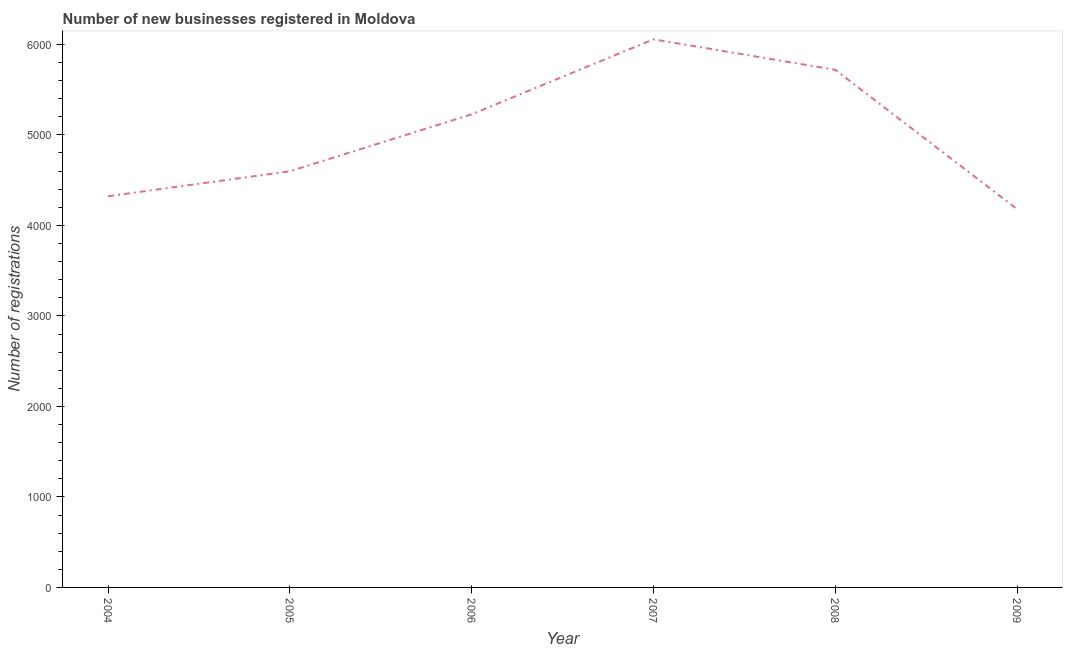What is the number of new business registrations in 2008?
Keep it short and to the point. 5719. Across all years, what is the maximum number of new business registrations?
Offer a very short reply. 6056. Across all years, what is the minimum number of new business registrations?
Provide a short and direct response. 4180. In which year was the number of new business registrations minimum?
Your response must be concise. 2009. What is the sum of the number of new business registrations?
Your answer should be compact. 3.01e+04. What is the difference between the number of new business registrations in 2004 and 2009?
Offer a terse response. 142. What is the average number of new business registrations per year?
Your response must be concise. 5017. What is the median number of new business registrations?
Offer a very short reply. 4912.5. In how many years, is the number of new business registrations greater than 4400 ?
Your answer should be compact. 4. Do a majority of the years between 2005 and 2008 (inclusive) have number of new business registrations greater than 4600 ?
Offer a very short reply. Yes. What is the ratio of the number of new business registrations in 2005 to that in 2009?
Offer a very short reply. 1.1. Is the number of new business registrations in 2004 less than that in 2006?
Keep it short and to the point. Yes. Is the difference between the number of new business registrations in 2005 and 2008 greater than the difference between any two years?
Keep it short and to the point. No. What is the difference between the highest and the second highest number of new business registrations?
Ensure brevity in your answer.  337. What is the difference between the highest and the lowest number of new business registrations?
Ensure brevity in your answer.  1876. Does the number of new business registrations monotonically increase over the years?
Your answer should be compact. No. How many lines are there?
Keep it short and to the point. 1. How many years are there in the graph?
Keep it short and to the point. 6. What is the difference between two consecutive major ticks on the Y-axis?
Your answer should be very brief. 1000. What is the title of the graph?
Offer a terse response. Number of new businesses registered in Moldova. What is the label or title of the Y-axis?
Your answer should be compact. Number of registrations. What is the Number of registrations of 2004?
Keep it short and to the point. 4322. What is the Number of registrations in 2005?
Give a very brief answer. 4598. What is the Number of registrations in 2006?
Your response must be concise. 5227. What is the Number of registrations in 2007?
Offer a very short reply. 6056. What is the Number of registrations in 2008?
Keep it short and to the point. 5719. What is the Number of registrations of 2009?
Your answer should be very brief. 4180. What is the difference between the Number of registrations in 2004 and 2005?
Your answer should be compact. -276. What is the difference between the Number of registrations in 2004 and 2006?
Offer a very short reply. -905. What is the difference between the Number of registrations in 2004 and 2007?
Make the answer very short. -1734. What is the difference between the Number of registrations in 2004 and 2008?
Ensure brevity in your answer.  -1397. What is the difference between the Number of registrations in 2004 and 2009?
Give a very brief answer. 142. What is the difference between the Number of registrations in 2005 and 2006?
Ensure brevity in your answer.  -629. What is the difference between the Number of registrations in 2005 and 2007?
Make the answer very short. -1458. What is the difference between the Number of registrations in 2005 and 2008?
Provide a succinct answer. -1121. What is the difference between the Number of registrations in 2005 and 2009?
Your response must be concise. 418. What is the difference between the Number of registrations in 2006 and 2007?
Your response must be concise. -829. What is the difference between the Number of registrations in 2006 and 2008?
Keep it short and to the point. -492. What is the difference between the Number of registrations in 2006 and 2009?
Offer a terse response. 1047. What is the difference between the Number of registrations in 2007 and 2008?
Your answer should be very brief. 337. What is the difference between the Number of registrations in 2007 and 2009?
Make the answer very short. 1876. What is the difference between the Number of registrations in 2008 and 2009?
Offer a very short reply. 1539. What is the ratio of the Number of registrations in 2004 to that in 2006?
Offer a very short reply. 0.83. What is the ratio of the Number of registrations in 2004 to that in 2007?
Ensure brevity in your answer.  0.71. What is the ratio of the Number of registrations in 2004 to that in 2008?
Your answer should be compact. 0.76. What is the ratio of the Number of registrations in 2004 to that in 2009?
Your answer should be very brief. 1.03. What is the ratio of the Number of registrations in 2005 to that in 2007?
Make the answer very short. 0.76. What is the ratio of the Number of registrations in 2005 to that in 2008?
Ensure brevity in your answer.  0.8. What is the ratio of the Number of registrations in 2006 to that in 2007?
Make the answer very short. 0.86. What is the ratio of the Number of registrations in 2006 to that in 2008?
Ensure brevity in your answer.  0.91. What is the ratio of the Number of registrations in 2007 to that in 2008?
Your answer should be very brief. 1.06. What is the ratio of the Number of registrations in 2007 to that in 2009?
Ensure brevity in your answer.  1.45. What is the ratio of the Number of registrations in 2008 to that in 2009?
Make the answer very short. 1.37. 